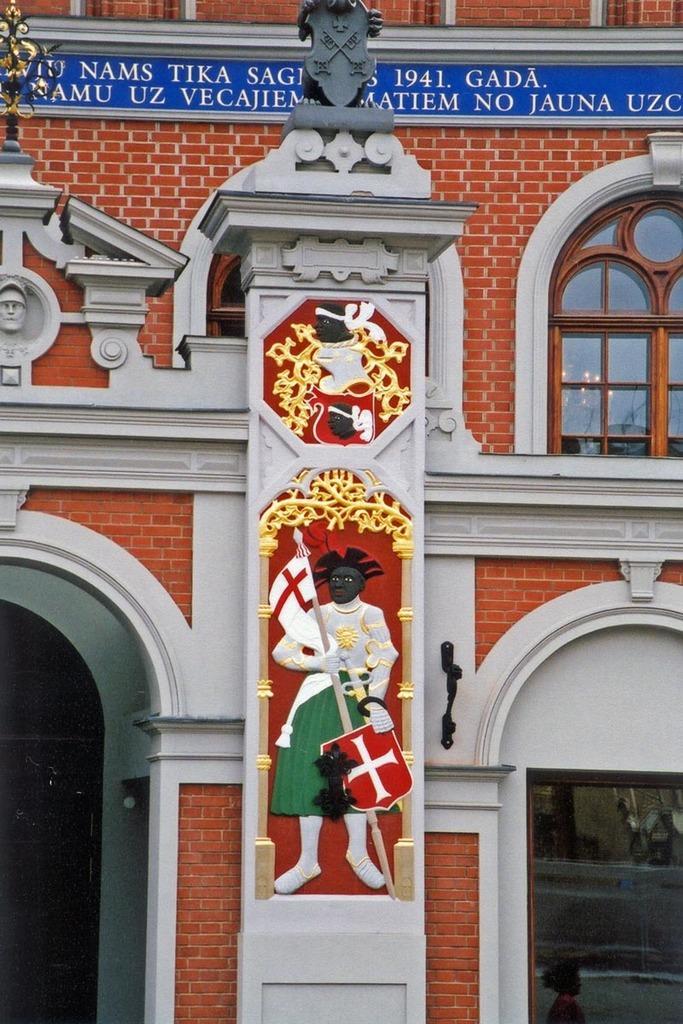How would you summarize this image in a sentence or two? In this picture we can observe a building. We can observe a pillar on which there are some carvings. We can observe white, green, red and black colors on the pillar. The building is in red color. 